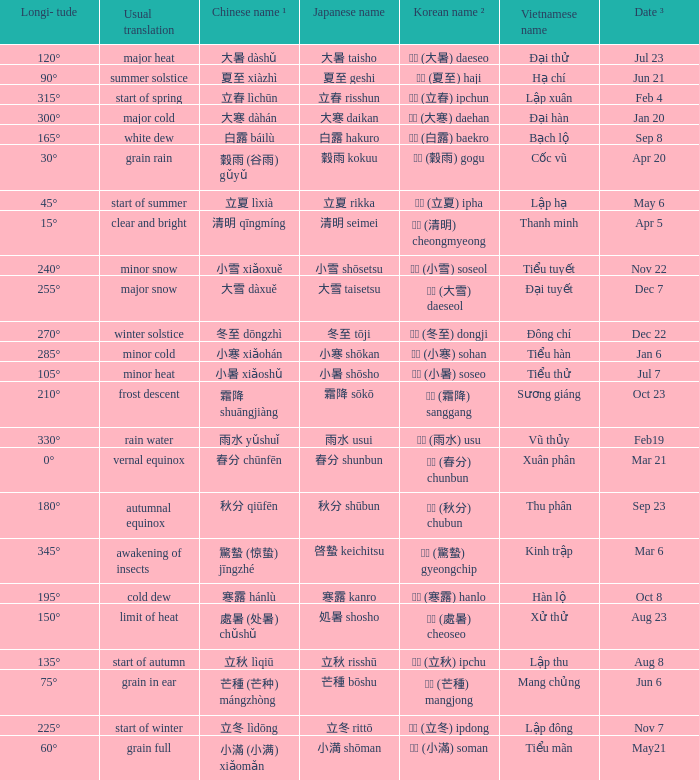Which Longi- tude is on jun 6? 75°. Write the full table. {'header': ['Longi- tude', 'Usual translation', 'Chinese name ¹', 'Japanese name', 'Korean name ²', 'Vietnamese name', 'Date ³'], 'rows': [['120°', 'major heat', '大暑 dàshǔ', '大暑 taisho', '대서 (大暑) daeseo', 'Đại thử', 'Jul 23'], ['90°', 'summer solstice', '夏至 xiàzhì', '夏至 geshi', '하지 (夏至) haji', 'Hạ chí', 'Jun 21'], ['315°', 'start of spring', '立春 lìchūn', '立春 risshun', '입춘 (立春) ipchun', 'Lập xuân', 'Feb 4'], ['300°', 'major cold', '大寒 dàhán', '大寒 daikan', '대한 (大寒) daehan', 'Đại hàn', 'Jan 20'], ['165°', 'white dew', '白露 báilù', '白露 hakuro', '백로 (白露) baekro', 'Bạch lộ', 'Sep 8'], ['30°', 'grain rain', '穀雨 (谷雨) gǔyǔ', '穀雨 kokuu', '곡우 (穀雨) gogu', 'Cốc vũ', 'Apr 20'], ['45°', 'start of summer', '立夏 lìxià', '立夏 rikka', '입하 (立夏) ipha', 'Lập hạ', 'May 6'], ['15°', 'clear and bright', '清明 qīngmíng', '清明 seimei', '청명 (清明) cheongmyeong', 'Thanh minh', 'Apr 5'], ['240°', 'minor snow', '小雪 xiǎoxuě', '小雪 shōsetsu', '소설 (小雪) soseol', 'Tiểu tuyết', 'Nov 22'], ['255°', 'major snow', '大雪 dàxuě', '大雪 taisetsu', '대설 (大雪) daeseol', 'Đại tuyết', 'Dec 7'], ['270°', 'winter solstice', '冬至 dōngzhì', '冬至 tōji', '동지 (冬至) dongji', 'Đông chí', 'Dec 22'], ['285°', 'minor cold', '小寒 xiǎohán', '小寒 shōkan', '소한 (小寒) sohan', 'Tiểu hàn', 'Jan 6'], ['105°', 'minor heat', '小暑 xiǎoshǔ', '小暑 shōsho', '소서 (小暑) soseo', 'Tiểu thử', 'Jul 7'], ['210°', 'frost descent', '霜降 shuāngjiàng', '霜降 sōkō', '상강 (霜降) sanggang', 'Sương giáng', 'Oct 23'], ['330°', 'rain water', '雨水 yǔshuǐ', '雨水 usui', '우수 (雨水) usu', 'Vũ thủy', 'Feb19'], ['0°', 'vernal equinox', '春分 chūnfēn', '春分 shunbun', '춘분 (春分) chunbun', 'Xuân phân', 'Mar 21'], ['180°', 'autumnal equinox', '秋分 qiūfēn', '秋分 shūbun', '추분 (秋分) chubun', 'Thu phân', 'Sep 23'], ['345°', 'awakening of insects', '驚蟄 (惊蛰) jīngzhé', '啓蟄 keichitsu', '경칩 (驚蟄) gyeongchip', 'Kinh trập', 'Mar 6'], ['195°', 'cold dew', '寒露 hánlù', '寒露 kanro', '한로 (寒露) hanlo', 'Hàn lộ', 'Oct 8'], ['150°', 'limit of heat', '處暑 (处暑) chǔshǔ', '処暑 shosho', '처서 (處暑) cheoseo', 'Xử thử', 'Aug 23'], ['135°', 'start of autumn', '立秋 lìqiū', '立秋 risshū', '입추 (立秋) ipchu', 'Lập thu', 'Aug 8'], ['75°', 'grain in ear', '芒種 (芒种) mángzhòng', '芒種 bōshu', '망종 (芒種) mangjong', 'Mang chủng', 'Jun 6'], ['225°', 'start of winter', '立冬 lìdōng', '立冬 rittō', '입동 (立冬) ipdong', 'Lập đông', 'Nov 7'], ['60°', 'grain full', '小滿 (小满) xiǎomǎn', '小満 shōman', '소만 (小滿) soman', 'Tiểu mãn', 'May21']]} 